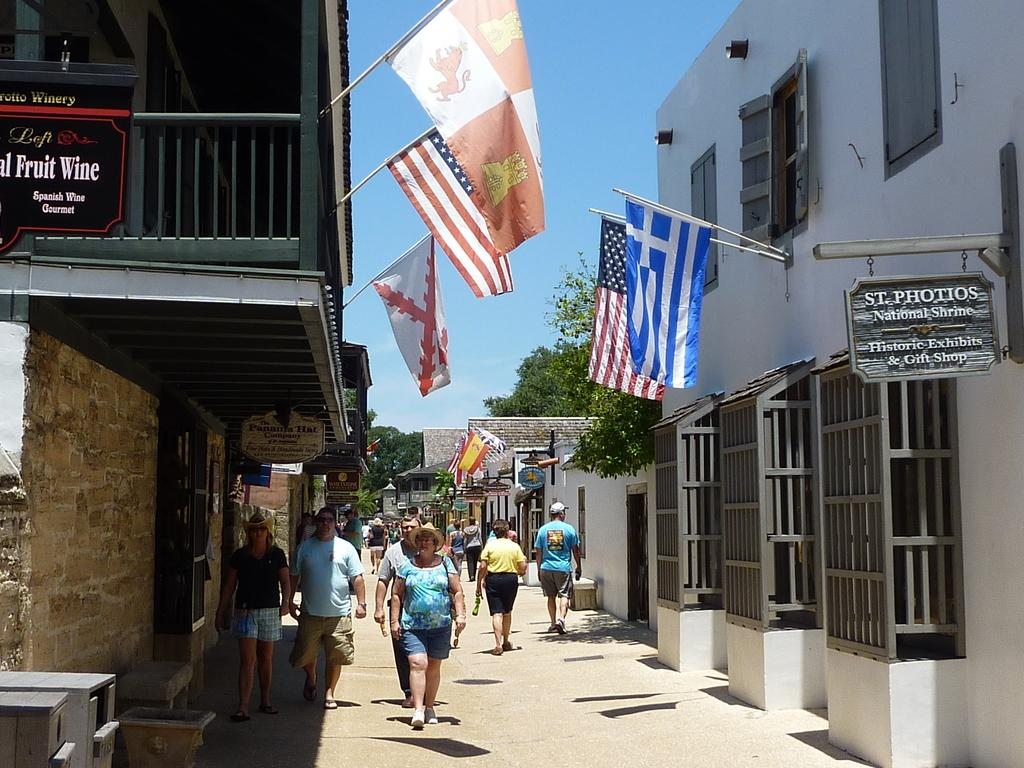How many people are in the image? There is a group of people in the image, but the exact number is not specified. What are the people in the image doing? The people are walking on the ground in the image. What structures can be seen in the image? There are buildings in the image. What other objects can be seen in the image? There are flags and trees in the image. What is visible in the background of the image? The sky is visible in the background of the image. What type of milk is being served at the event in the image? There is no event or milk present in the image; it features a group of people walking on the ground with buildings, flags, and trees in the background. How many oranges are visible in the image? There are no oranges present in the image. 